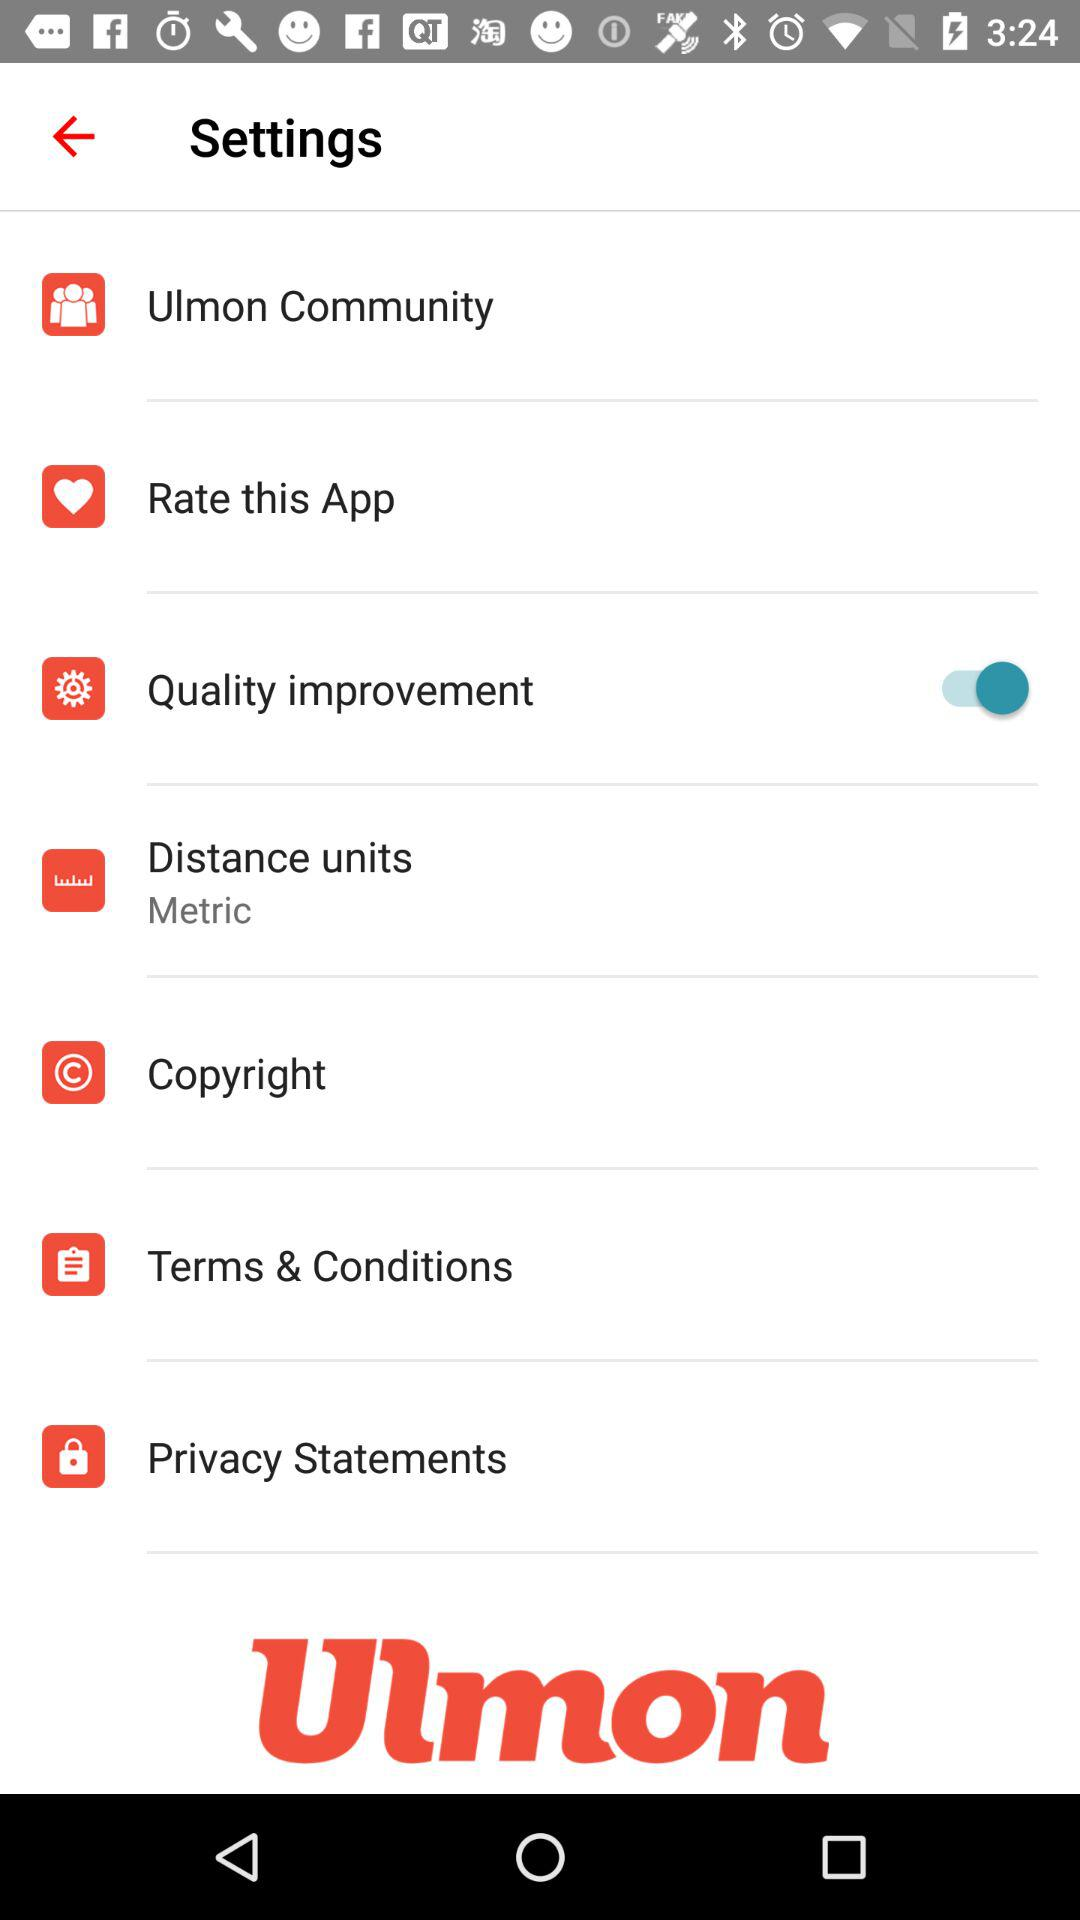How many items have a switch?
Answer the question using a single word or phrase. 1 